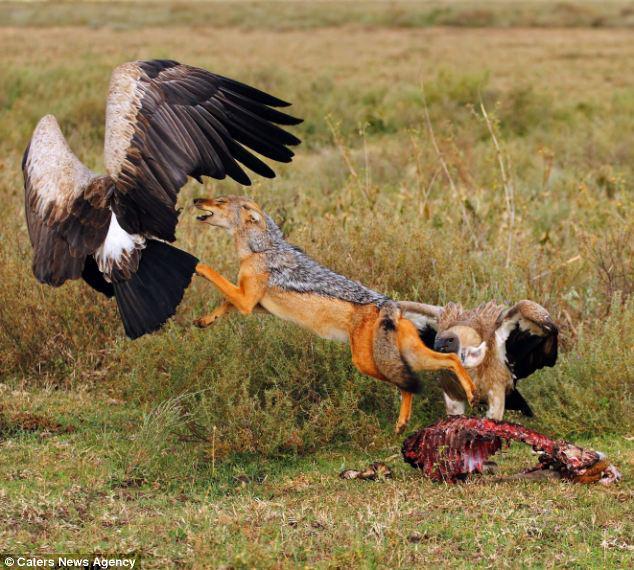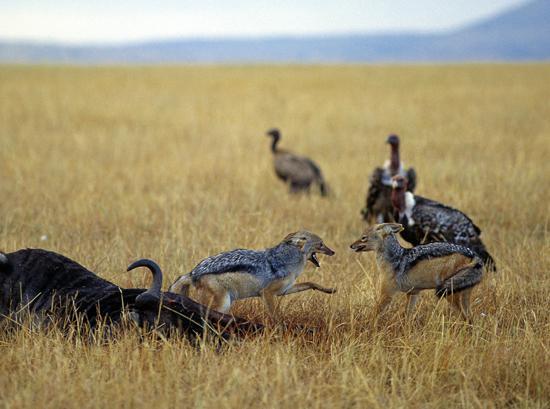The first image is the image on the left, the second image is the image on the right. Examine the images to the left and right. Is the description "There is exactly one brown dog in the image on the left." accurate? Answer yes or no. Yes. 